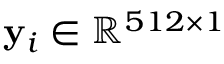Convert formula to latex. <formula><loc_0><loc_0><loc_500><loc_500>y _ { i } \in \mathbb { R } ^ { 5 1 2 \times 1 }</formula> 